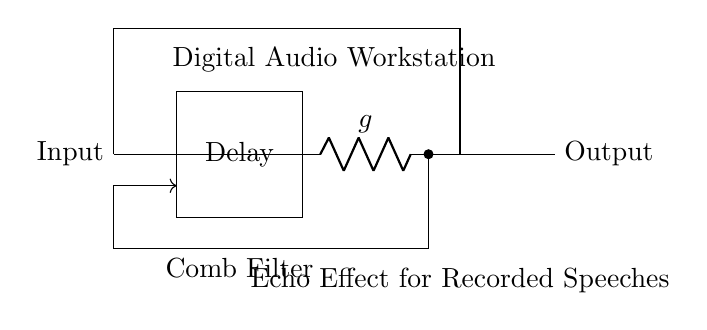What is the main component in the circuit? The main component is the comb filter, which is represented as a rectangle labeled "Delay" with additional components for attenuation and summing.
Answer: Comb filter What is the purpose of the delay block? The delay block introduces a time shift, which is essential for creating the echo effect by delaying the input signal before summing it with the original signal.
Answer: Echo effect What does the resistor labeled 'g' represent? The resistor labeled 'g' is an attenuator that reduces the amplitude of the delayed signal before it is summed with the input signal.
Answer: Attenuation How does the feedback path function in this circuit? The feedback path routes a portion of the output back into the input to reinforce the delayed signal, creating a repeated echo effect in the output.
Answer: Feedback What type of effect is this circuit primarily used for? The circuit is primarily used for creating an echo effect, particularly in recorded speeches, as indicated in the labels.
Answer: Echo effect 